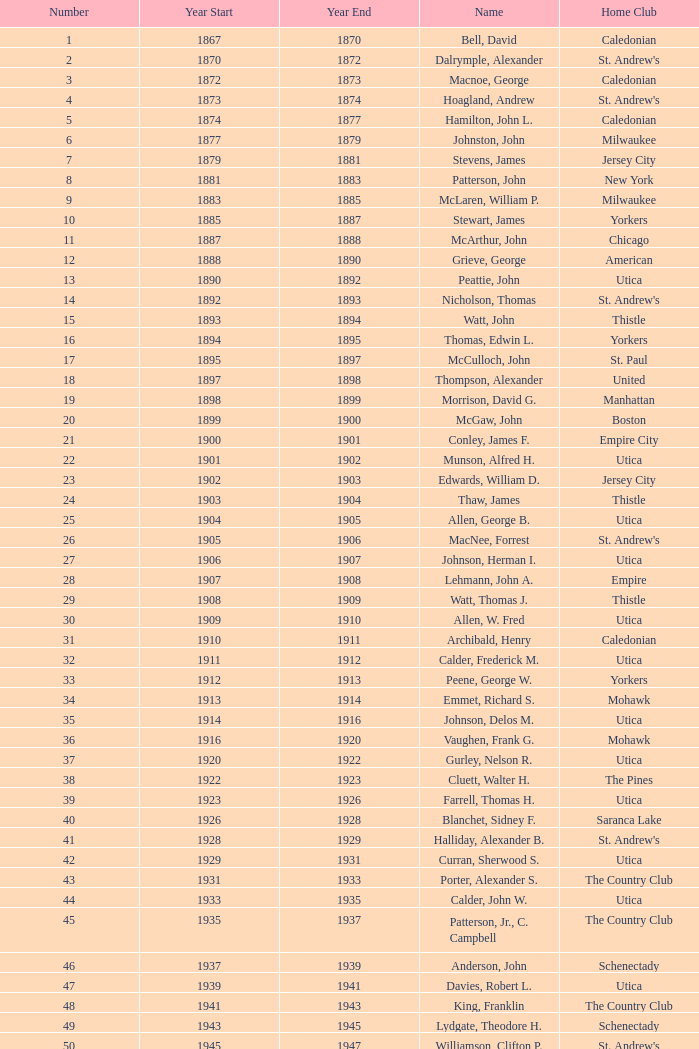Could you help me parse every detail presented in this table? {'header': ['Number', 'Year Start', 'Year End', 'Name', 'Home Club'], 'rows': [['1', '1867', '1870', 'Bell, David', 'Caledonian'], ['2', '1870', '1872', 'Dalrymple, Alexander', "St. Andrew's"], ['3', '1872', '1873', 'Macnoe, George', 'Caledonian'], ['4', '1873', '1874', 'Hoagland, Andrew', "St. Andrew's"], ['5', '1874', '1877', 'Hamilton, John L.', 'Caledonian'], ['6', '1877', '1879', 'Johnston, John', 'Milwaukee'], ['7', '1879', '1881', 'Stevens, James', 'Jersey City'], ['8', '1881', '1883', 'Patterson, John', 'New York'], ['9', '1883', '1885', 'McLaren, William P.', 'Milwaukee'], ['10', '1885', '1887', 'Stewart, James', 'Yorkers'], ['11', '1887', '1888', 'McArthur, John', 'Chicago'], ['12', '1888', '1890', 'Grieve, George', 'American'], ['13', '1890', '1892', 'Peattie, John', 'Utica'], ['14', '1892', '1893', 'Nicholson, Thomas', "St. Andrew's"], ['15', '1893', '1894', 'Watt, John', 'Thistle'], ['16', '1894', '1895', 'Thomas, Edwin L.', 'Yorkers'], ['17', '1895', '1897', 'McCulloch, John', 'St. Paul'], ['18', '1897', '1898', 'Thompson, Alexander', 'United'], ['19', '1898', '1899', 'Morrison, David G.', 'Manhattan'], ['20', '1899', '1900', 'McGaw, John', 'Boston'], ['21', '1900', '1901', 'Conley, James F.', 'Empire City'], ['22', '1901', '1902', 'Munson, Alfred H.', 'Utica'], ['23', '1902', '1903', 'Edwards, William D.', 'Jersey City'], ['24', '1903', '1904', 'Thaw, James', 'Thistle'], ['25', '1904', '1905', 'Allen, George B.', 'Utica'], ['26', '1905', '1906', 'MacNee, Forrest', "St. Andrew's"], ['27', '1906', '1907', 'Johnson, Herman I.', 'Utica'], ['28', '1907', '1908', 'Lehmann, John A.', 'Empire'], ['29', '1908', '1909', 'Watt, Thomas J.', 'Thistle'], ['30', '1909', '1910', 'Allen, W. Fred', 'Utica'], ['31', '1910', '1911', 'Archibald, Henry', 'Caledonian'], ['32', '1911', '1912', 'Calder, Frederick M.', 'Utica'], ['33', '1912', '1913', 'Peene, George W.', 'Yorkers'], ['34', '1913', '1914', 'Emmet, Richard S.', 'Mohawk'], ['35', '1914', '1916', 'Johnson, Delos M.', 'Utica'], ['36', '1916', '1920', 'Vaughen, Frank G.', 'Mohawk'], ['37', '1920', '1922', 'Gurley, Nelson R.', 'Utica'], ['38', '1922', '1923', 'Cluett, Walter H.', 'The Pines'], ['39', '1923', '1926', 'Farrell, Thomas H.', 'Utica'], ['40', '1926', '1928', 'Blanchet, Sidney F.', 'Saranca Lake'], ['41', '1928', '1929', 'Halliday, Alexander B.', "St. Andrew's"], ['42', '1929', '1931', 'Curran, Sherwood S.', 'Utica'], ['43', '1931', '1933', 'Porter, Alexander S.', 'The Country Club'], ['44', '1933', '1935', 'Calder, John W.', 'Utica'], ['45', '1935', '1937', 'Patterson, Jr., C. Campbell', 'The Country Club'], ['46', '1937', '1939', 'Anderson, John', 'Schenectady'], ['47', '1939', '1941', 'Davies, Robert L.', 'Utica'], ['48', '1941', '1943', 'King, Franklin', 'The Country Club'], ['49', '1943', '1945', 'Lydgate, Theodore H.', 'Schenectady'], ['50', '1945', '1947', 'Williamson, Clifton P.', "St. Andrew's"], ['51', '1947', '1949', 'Hurd, Kenneth S.', 'Utica'], ['52', '1949', '1951', 'Hastings, Addison B.', 'Ardsley'], ['53', '1951', '1953', 'Hill, Lucius T.', 'The Country Club'], ['54', '1953', '1954', 'Davis, Richard P.', 'Schenectady'], ['55', '1954', '1956', 'Joy, John H.', 'Winchester'], ['56', '1956', '1957', 'Searle, William A.', 'Utica'], ['57', '1957', '1958', 'Smith, Dr. Deering G.', 'Nashua'], ['58', '1958', '1959', 'Seibert, W. Lincoln', "St. Andrew's"], ['59', '1959', '1961', 'Reid, Ralston B.', 'Schenectady'], ['60', '1961', '1963', 'Cushing, Henry K.', 'The Country Club'], ['61', '1963', '1965', 'Wood, Brenner R.', 'Ardsley'], ['62', '1965', '1966', 'Parkinson, Fred E.', 'Utica'], ['63', '1966', '1968', 'Childs, Edward C.', 'Norfolk'], ['64', '1968', '1970', 'Rand, Grenfell N.', 'Albany'], ['65', '1970', '1972', 'Neill, Stanley E.', 'Winchester'], ['66', '1972', '1974', 'Milano, Dr. Joseph E.', 'NY Caledonian'], ['67', '1974', '1976', 'Neuber, Dr. Richard A.', 'Schenectady'], ['68', '1976', '1978', 'Cobb, Arthur J.', 'Utica'], ['69', '1978', '1980', 'Hamm, Arthur E.', 'Petersham'], ['70', '1980', '1982', 'Will, A. Roland', 'Nutmeg'], ['71', '1982', '1984', 'Cooper, C. Kenneth', 'NY Caledonian'], ['72', '1984', '1986', 'Porter, David R.', 'Wellesley'], ['73', '1984', '1986', 'Millington, A. Wesley', 'Schenectady'], ['74', '1988', '1989', 'Dewees, Dr. David C.', 'Cape Cod'], ['75', '1989', '1991', 'Owens, Charles D.', 'Nutmeg'], ['76', '1991', '1993', 'Mitchell, J. Peter', 'Garden State'], ['77', '1993', '1995', 'Lopez, Jr., Chester H.', 'Nashua'], ['78', '1995', '1997', 'Freeman, Kim', 'Schenectady'], ['79', '1997', '1999', 'Williams, Samuel C.', 'Broomstones'], ['80', '1999', '2001', 'Hatch, Peggy', 'Philadelphia'], ['81', '2001', '2003', 'Garber, Thomas', 'Utica'], ['82', '2003', '2005', 'Pelletier, Robert', 'Potomac'], ['83', '2005', '2007', 'Chandler, Robert P.', 'Broomstones'], ['84', '2007', '2009', 'Krailo, Gwen', 'Nashua'], ['85', '2009', '2011', 'Thomas, Carl', 'Utica'], ['86', '2011', '2013', 'Macartney, Dick', 'Coastal Carolina']]} For which number does the initial year precede 1874 and the final year surpass 1873? 4.0. 